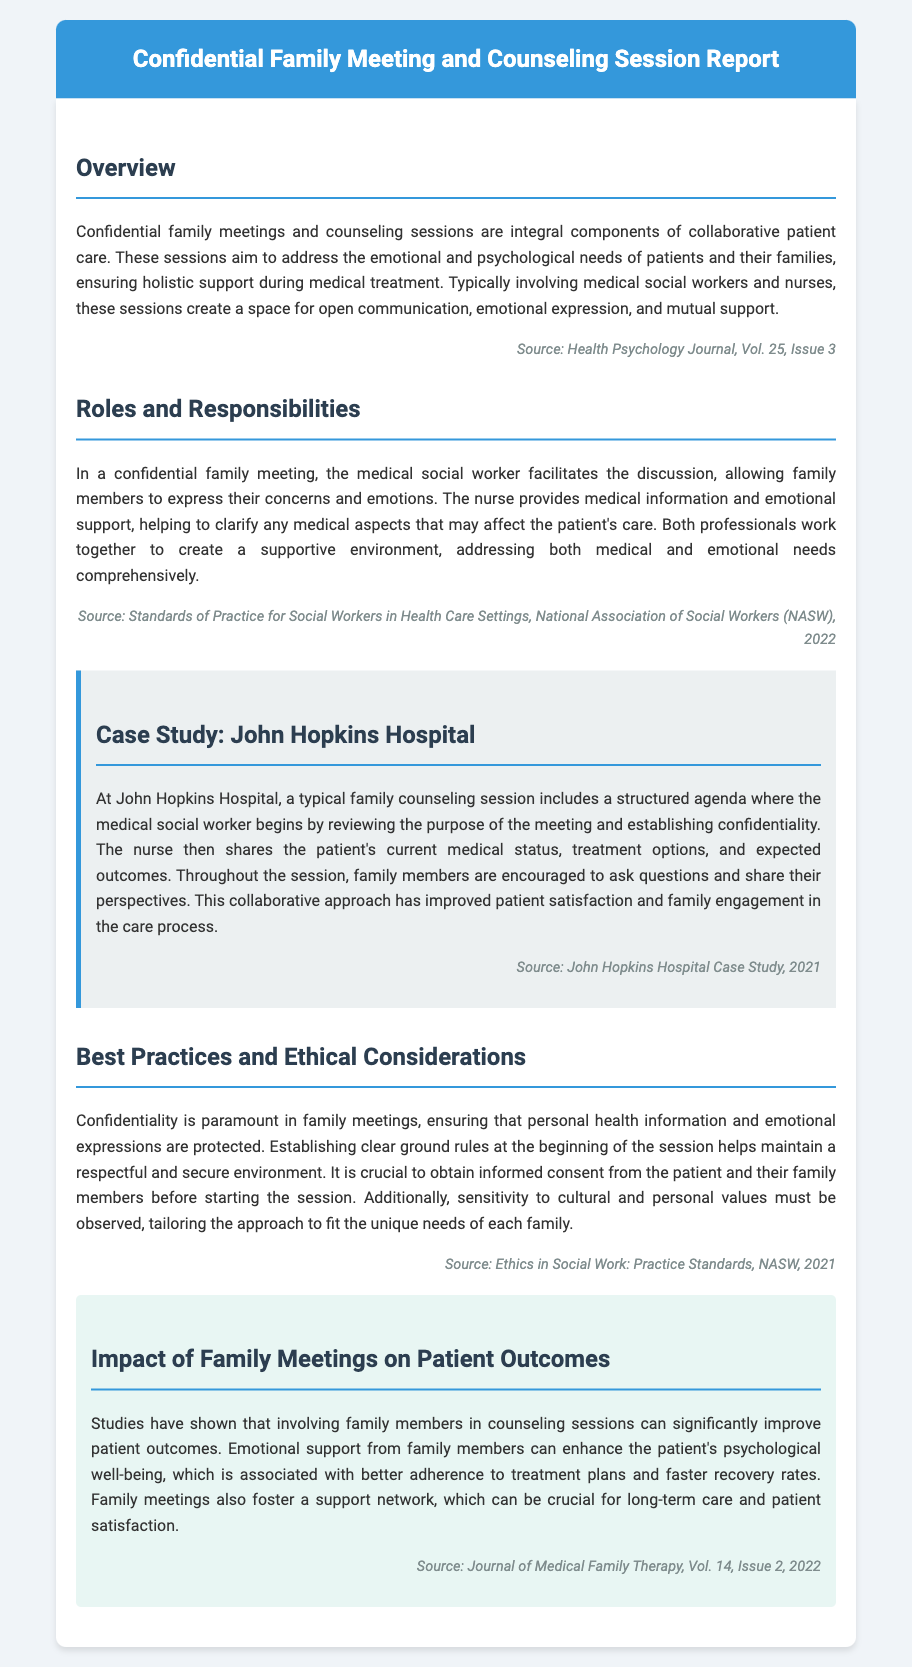What is the title of the report? The title of the report is indicated at the top of the document in the header section.
Answer: Confidential Family Meeting and Counseling Session Report Who typically facilitates the discussion in a family meeting? The document mentions that the medical social worker facilitates the discussion during a family meeting.
Answer: Medical social worker What is the main purpose of these sessions? The purpose is described in the overview section as addressing emotional and psychological needs during medical treatment.
Answer: Address emotional and psychological needs What is a crucial ethical consideration mentioned in the document? The document emphasizes the importance of confidentiality in family meetings as a key ethical consideration.
Answer: Confidentiality Which hospital is used as a case study in the report? The document provides a specific case study, naming a well-known hospital that exemplifies effective family counseling sessions.
Answer: John Hopkins Hospital How have family meetings impacted patient satisfaction according to the document? The document indicates that family meetings have improved patient satisfaction and family engagement within the care process.
Answer: Improved patient satisfaction What year was the case study from John Hopkins Hospital published? The case study citation in the document specifies the year of publication.
Answer: 2021 What aspect of family meetings is highlighted as beneficial to treatment adherence? The document discusses emotional support from family members as a factor that enhances adherence to treatment plans.
Answer: Emotional support In which volume and issue of the journal is the impact of family meetings published? The document provides details about a specific journal that contains findings regarding the effects of family meetings on patient outcomes.
Answer: Volume 14, Issue 2 